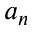Convert formula to latex. <formula><loc_0><loc_0><loc_500><loc_500>a _ { n }</formula> 